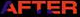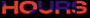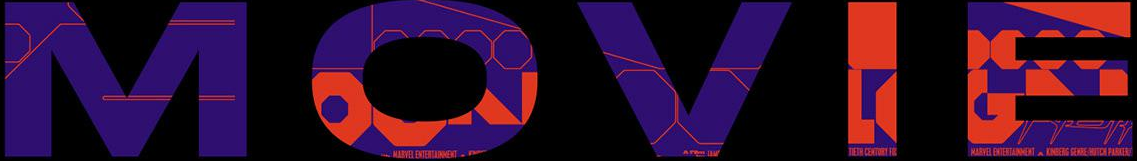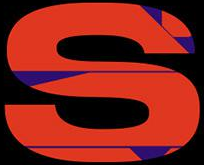What text appears in these images from left to right, separated by a semicolon? AFTER; HOURS; MOVIE; S 